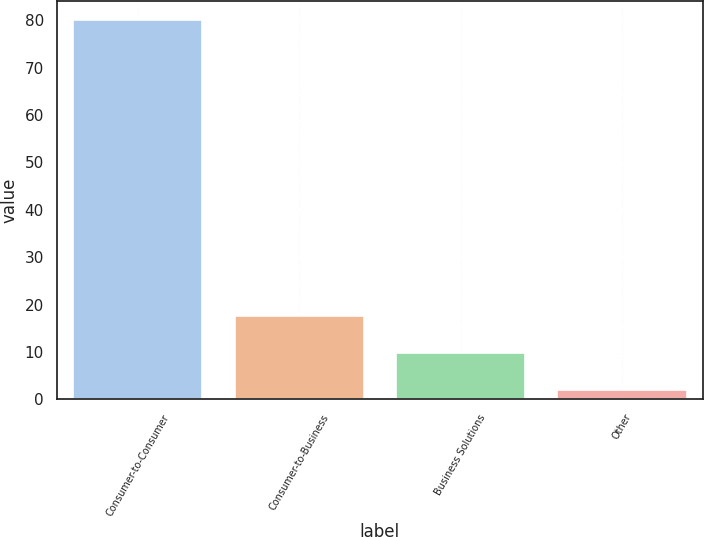<chart> <loc_0><loc_0><loc_500><loc_500><bar_chart><fcel>Consumer-to-Consumer<fcel>Consumer-to-Business<fcel>Business Solutions<fcel>Other<nl><fcel>80<fcel>17.6<fcel>9.8<fcel>2<nl></chart> 